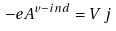<formula> <loc_0><loc_0><loc_500><loc_500>- e A ^ { v - i n d } = V \, j \\</formula> 